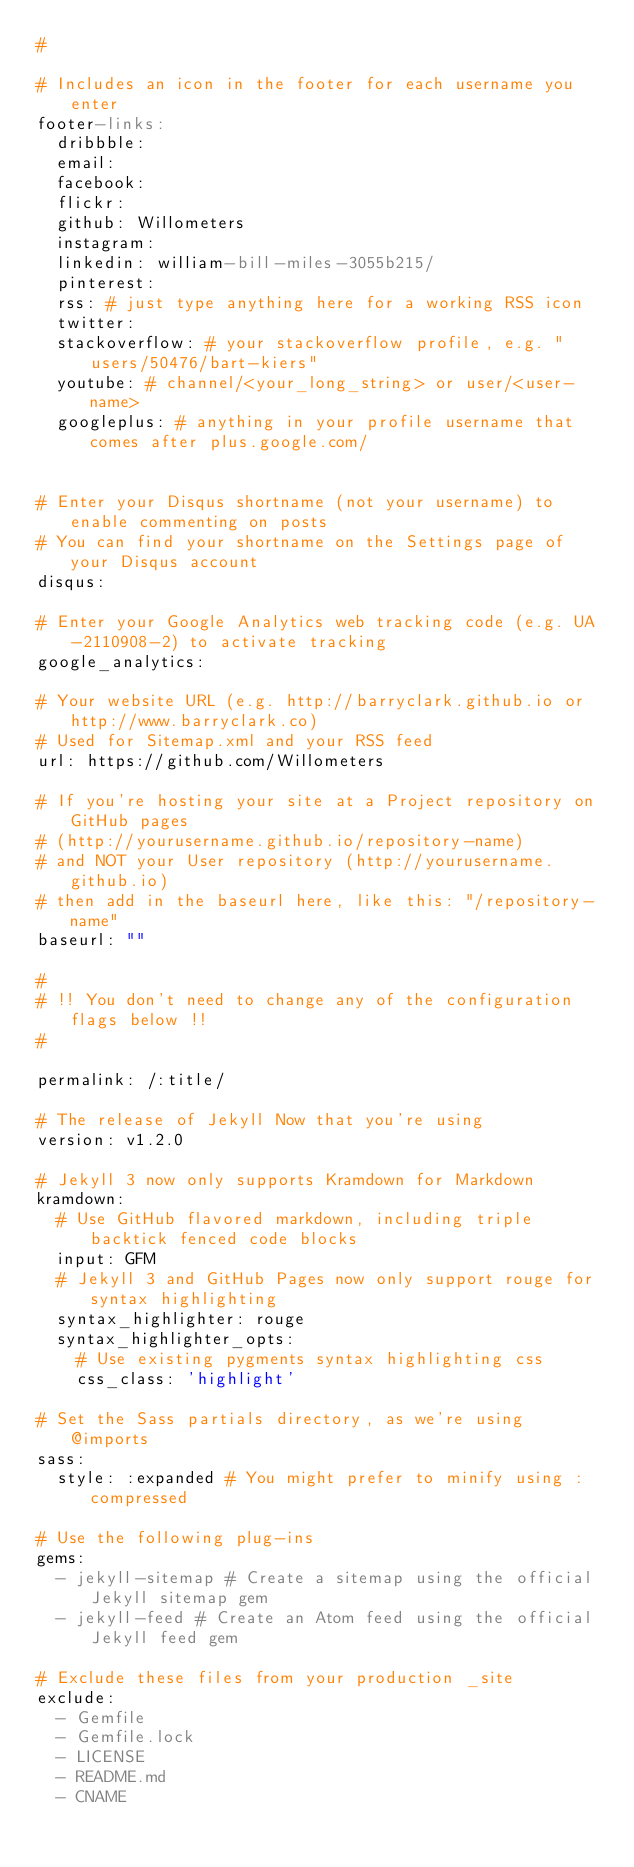Convert code to text. <code><loc_0><loc_0><loc_500><loc_500><_YAML_>#

# Includes an icon in the footer for each username you enter
footer-links:
  dribbble:
  email:
  facebook:
  flickr:
  github: Willometers
  instagram:
  linkedin: william-bill-miles-3055b215/
  pinterest:
  rss: # just type anything here for a working RSS icon
  twitter: 
  stackoverflow: # your stackoverflow profile, e.g. "users/50476/bart-kiers"
  youtube: # channel/<your_long_string> or user/<user-name>
  googleplus: # anything in your profile username that comes after plus.google.com/


# Enter your Disqus shortname (not your username) to enable commenting on posts
# You can find your shortname on the Settings page of your Disqus account
disqus:

# Enter your Google Analytics web tracking code (e.g. UA-2110908-2) to activate tracking
google_analytics:

# Your website URL (e.g. http://barryclark.github.io or http://www.barryclark.co)
# Used for Sitemap.xml and your RSS feed
url: https://github.com/Willometers

# If you're hosting your site at a Project repository on GitHub pages
# (http://yourusername.github.io/repository-name)
# and NOT your User repository (http://yourusername.github.io)
# then add in the baseurl here, like this: "/repository-name"
baseurl: ""

#
# !! You don't need to change any of the configuration flags below !!
#

permalink: /:title/

# The release of Jekyll Now that you're using
version: v1.2.0

# Jekyll 3 now only supports Kramdown for Markdown
kramdown:
  # Use GitHub flavored markdown, including triple backtick fenced code blocks
  input: GFM
  # Jekyll 3 and GitHub Pages now only support rouge for syntax highlighting
  syntax_highlighter: rouge
  syntax_highlighter_opts:
    # Use existing pygments syntax highlighting css
    css_class: 'highlight'

# Set the Sass partials directory, as we're using @imports
sass:
  style: :expanded # You might prefer to minify using :compressed

# Use the following plug-ins
gems:
  - jekyll-sitemap # Create a sitemap using the official Jekyll sitemap gem
  - jekyll-feed # Create an Atom feed using the official Jekyll feed gem

# Exclude these files from your production _site
exclude:
  - Gemfile
  - Gemfile.lock
  - LICENSE
  - README.md
  - CNAME
</code> 